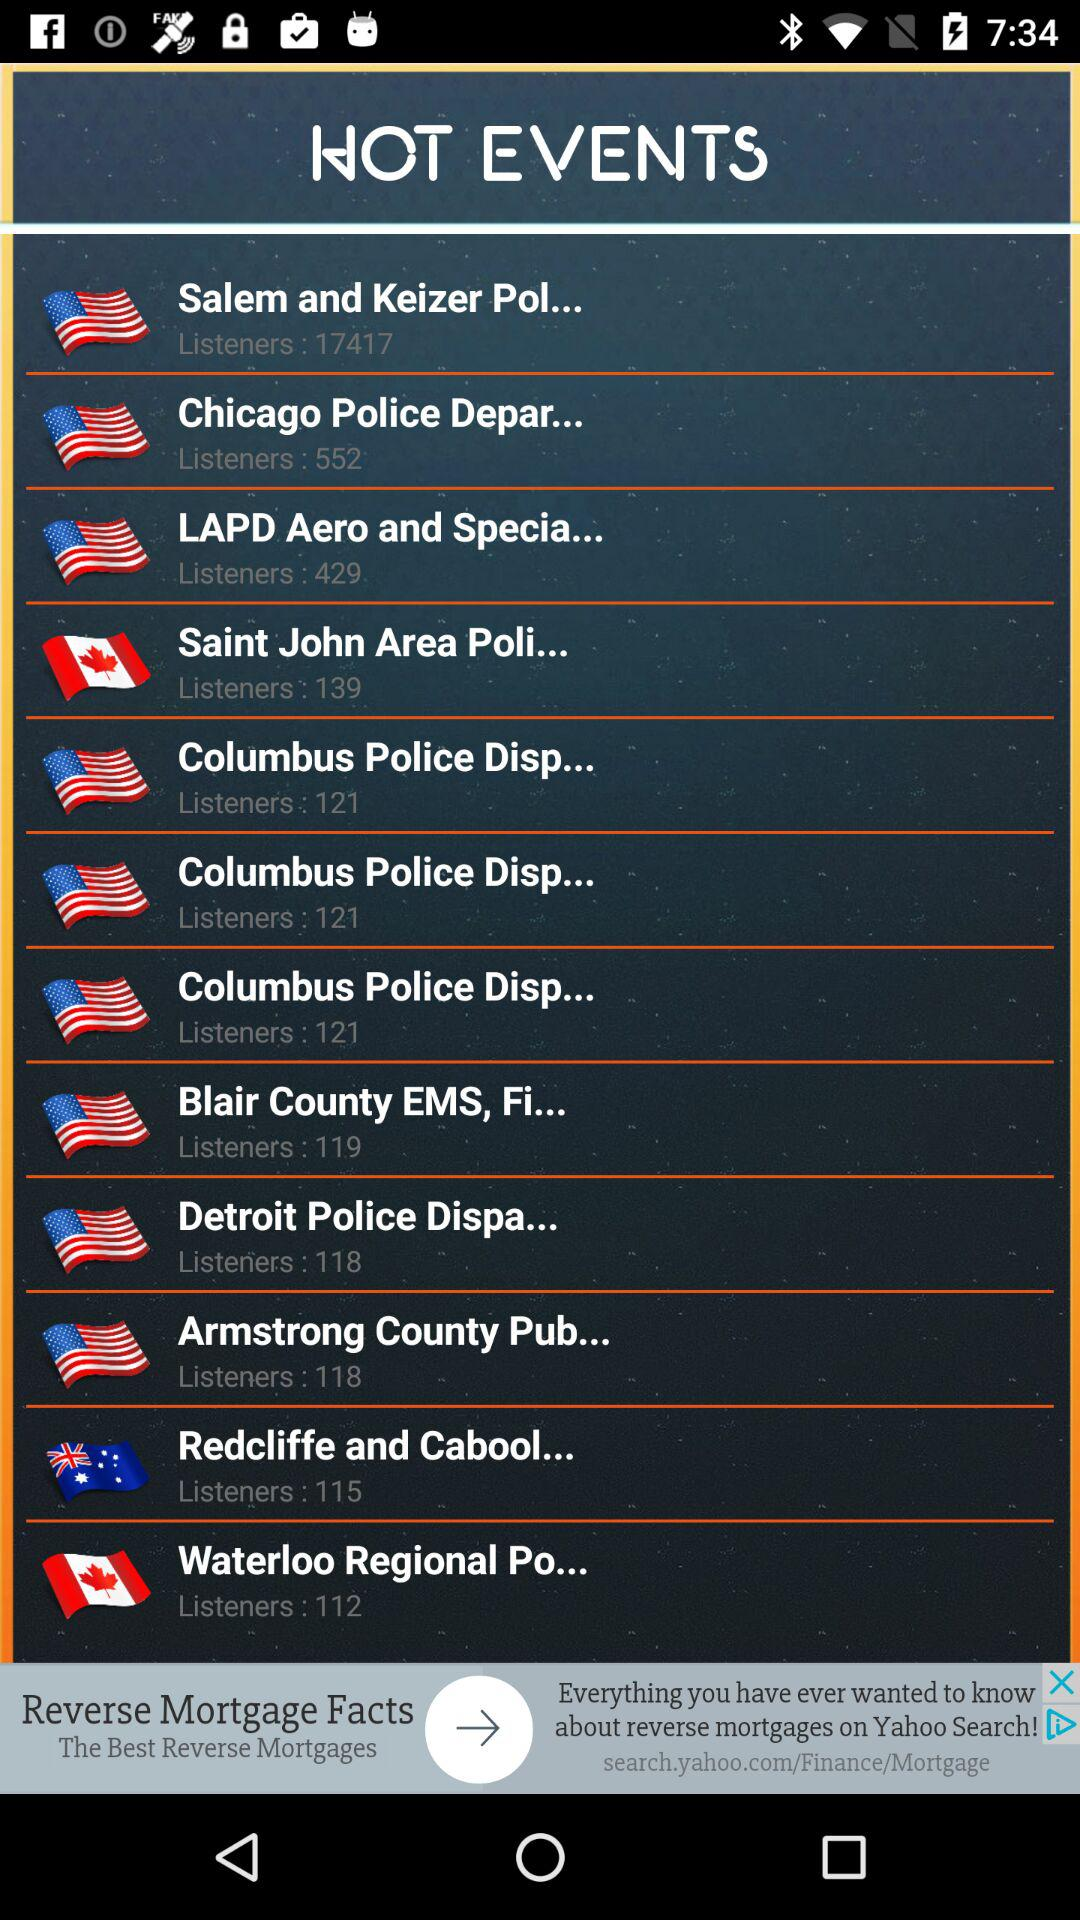Which event has 552 listeners? The event which has 552 listeners is "Chicago Police Depar...". 